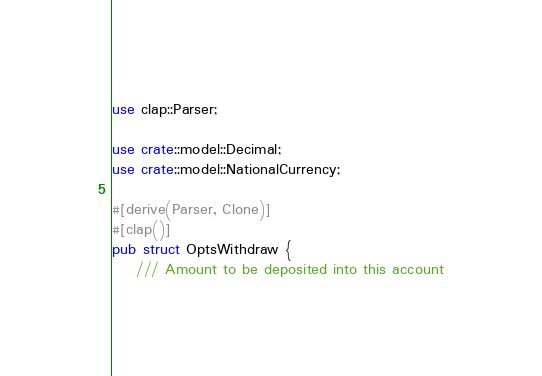<code> <loc_0><loc_0><loc_500><loc_500><_Rust_>use clap::Parser;

use crate::model::Decimal;
use crate::model::NationalCurrency;

#[derive(Parser, Clone)]
#[clap()]
pub struct OptsWithdraw {
    /// Amount to be deposited into this account</code> 